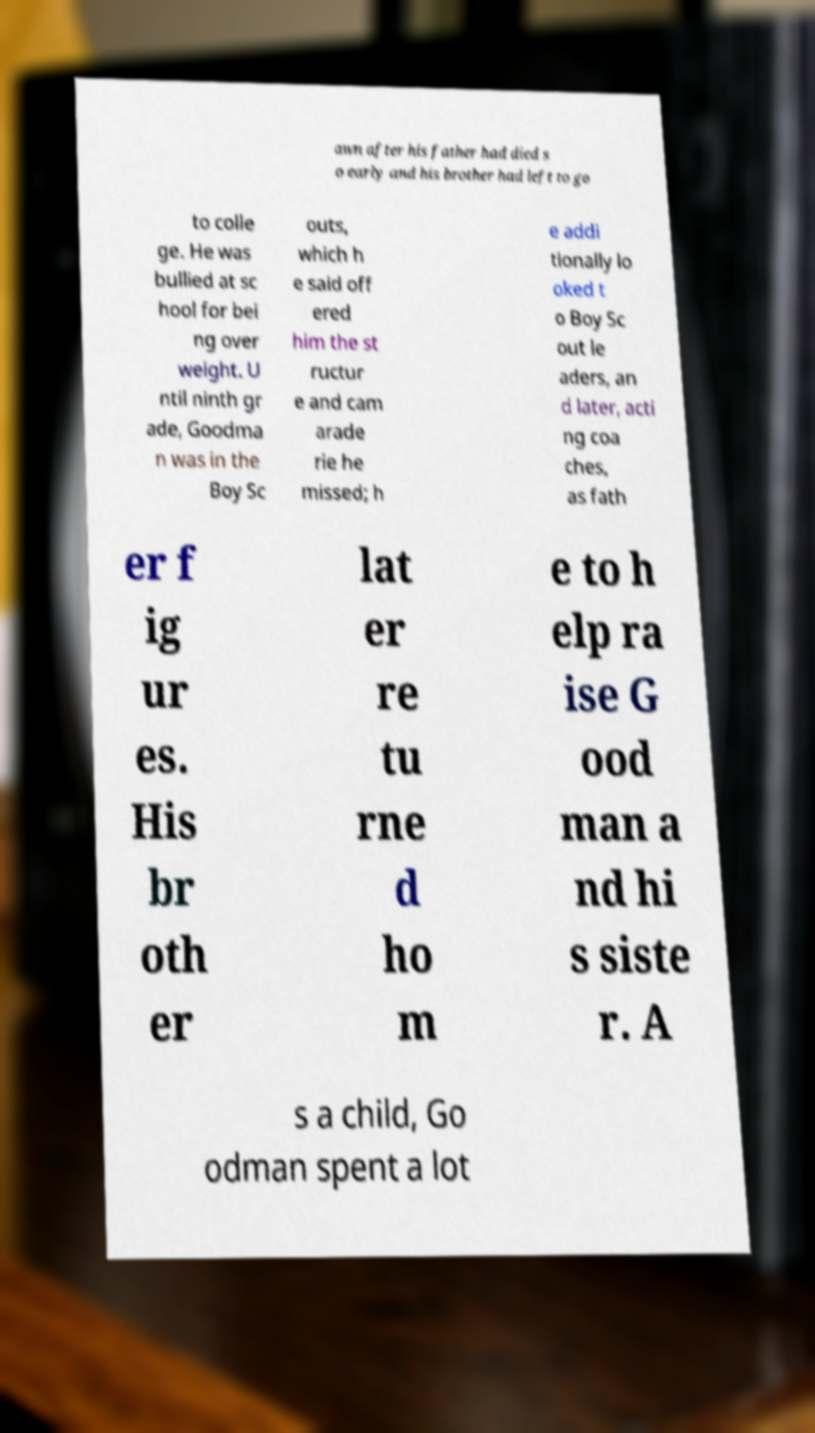Could you assist in decoding the text presented in this image and type it out clearly? awn after his father had died s o early and his brother had left to go to colle ge. He was bullied at sc hool for bei ng over weight. U ntil ninth gr ade, Goodma n was in the Boy Sc outs, which h e said off ered him the st ructur e and cam arade rie he missed; h e addi tionally lo oked t o Boy Sc out le aders, an d later, acti ng coa ches, as fath er f ig ur es. His br oth er lat er re tu rne d ho m e to h elp ra ise G ood man a nd hi s siste r. A s a child, Go odman spent a lot 